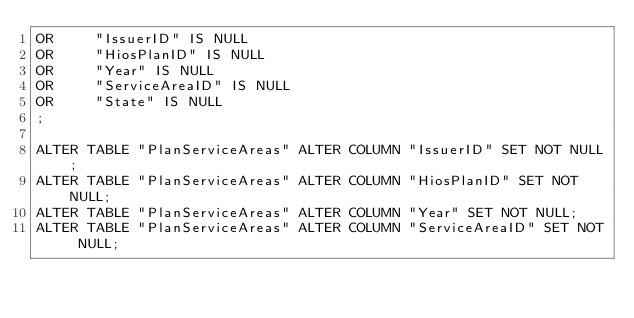<code> <loc_0><loc_0><loc_500><loc_500><_SQL_>OR     "IssuerID" IS NULL
OR     "HiosPlanID" IS NULL
OR     "Year" IS NULL
OR     "ServiceAreaID" IS NULL
OR     "State" IS NULL
;

ALTER TABLE "PlanServiceAreas" ALTER COLUMN "IssuerID" SET NOT NULL;
ALTER TABLE "PlanServiceAreas" ALTER COLUMN "HiosPlanID" SET NOT NULL;
ALTER TABLE "PlanServiceAreas" ALTER COLUMN "Year" SET NOT NULL;
ALTER TABLE "PlanServiceAreas" ALTER COLUMN "ServiceAreaID" SET NOT NULL;</code> 